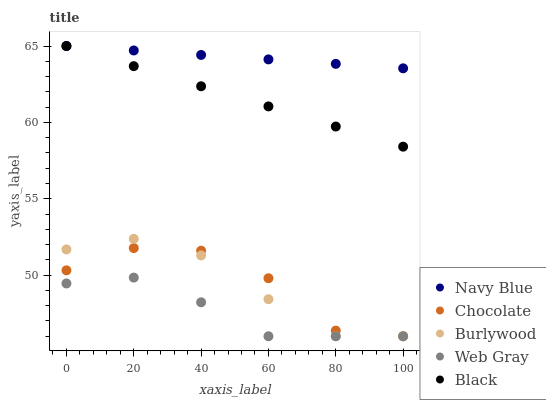Does Web Gray have the minimum area under the curve?
Answer yes or no. Yes. Does Navy Blue have the maximum area under the curve?
Answer yes or no. Yes. Does Navy Blue have the minimum area under the curve?
Answer yes or no. No. Does Web Gray have the maximum area under the curve?
Answer yes or no. No. Is Black the smoothest?
Answer yes or no. Yes. Is Chocolate the roughest?
Answer yes or no. Yes. Is Navy Blue the smoothest?
Answer yes or no. No. Is Navy Blue the roughest?
Answer yes or no. No. Does Burlywood have the lowest value?
Answer yes or no. Yes. Does Navy Blue have the lowest value?
Answer yes or no. No. Does Black have the highest value?
Answer yes or no. Yes. Does Web Gray have the highest value?
Answer yes or no. No. Is Web Gray less than Navy Blue?
Answer yes or no. Yes. Is Navy Blue greater than Web Gray?
Answer yes or no. Yes. Does Web Gray intersect Burlywood?
Answer yes or no. Yes. Is Web Gray less than Burlywood?
Answer yes or no. No. Is Web Gray greater than Burlywood?
Answer yes or no. No. Does Web Gray intersect Navy Blue?
Answer yes or no. No. 